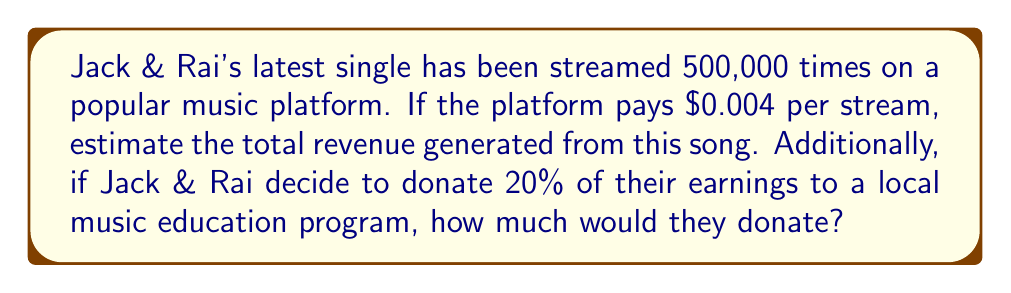What is the answer to this math problem? Let's break this down step-by-step:

1. Calculate the total revenue from streams:
   * Number of streams = 500,000
   * Payment per stream = $0.004
   * Total revenue = Number of streams × Payment per stream
   * Total revenue = $500,000 \times $0.004 = $2,000

2. Calculate the donation amount:
   * Donation percentage = 20% = 0.20
   * Donation amount = Total revenue × Donation percentage
   * Donation amount = $2,000 \times 0.20 = $400

The calculation can be represented as:

$$\text{Total Revenue} = 500,000 \times $0.004 = $2,000$$
$$\text{Donation} = $2,000 \times 0.20 = $400$$
Answer: $2,000 total revenue; $400 donation 